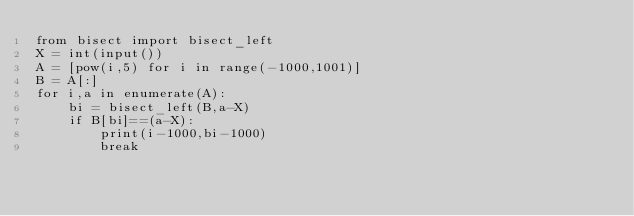Convert code to text. <code><loc_0><loc_0><loc_500><loc_500><_Python_>from bisect import bisect_left
X = int(input())
A = [pow(i,5) for i in range(-1000,1001)]
B = A[:]
for i,a in enumerate(A):
    bi = bisect_left(B,a-X)
    if B[bi]==(a-X):
        print(i-1000,bi-1000)
        break</code> 